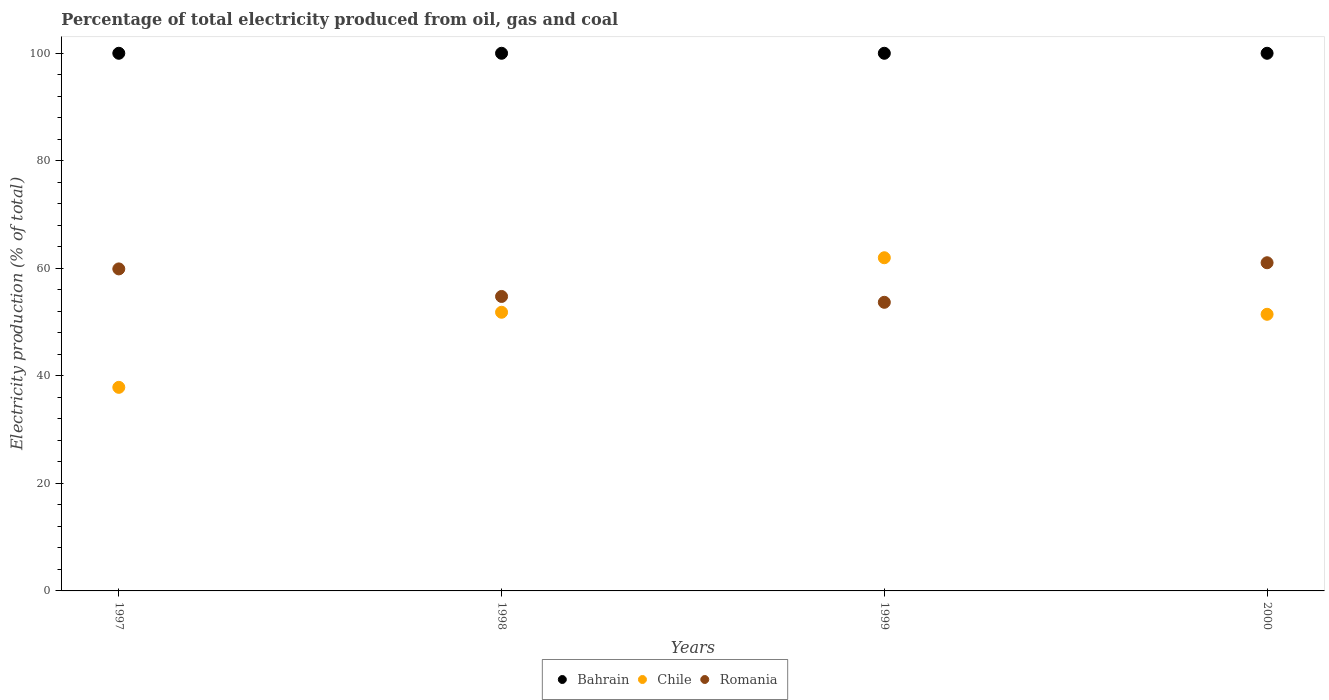What is the electricity production in in Romania in 2000?
Provide a succinct answer. 61.04. Across all years, what is the maximum electricity production in in Bahrain?
Provide a short and direct response. 100. Across all years, what is the minimum electricity production in in Bahrain?
Provide a succinct answer. 100. In which year was the electricity production in in Chile minimum?
Provide a short and direct response. 1997. What is the total electricity production in in Chile in the graph?
Provide a succinct answer. 203.12. What is the difference between the electricity production in in Bahrain in 1997 and that in 2000?
Your response must be concise. 0. What is the difference between the electricity production in in Chile in 1997 and the electricity production in in Romania in 2000?
Your answer should be compact. -23.17. What is the average electricity production in in Romania per year?
Keep it short and to the point. 57.35. In the year 2000, what is the difference between the electricity production in in Romania and electricity production in in Bahrain?
Your answer should be compact. -38.96. What is the ratio of the electricity production in in Romania in 1997 to that in 1998?
Provide a succinct answer. 1.09. What is the difference between the highest and the second highest electricity production in in Chile?
Provide a succinct answer. 10.14. What is the difference between the highest and the lowest electricity production in in Chile?
Give a very brief answer. 24.1. Is the sum of the electricity production in in Romania in 1997 and 1998 greater than the maximum electricity production in in Bahrain across all years?
Your response must be concise. Yes. Does the electricity production in in Chile monotonically increase over the years?
Make the answer very short. No. Is the electricity production in in Bahrain strictly less than the electricity production in in Romania over the years?
Ensure brevity in your answer.  No. How many dotlines are there?
Offer a terse response. 3. What is the difference between two consecutive major ticks on the Y-axis?
Provide a short and direct response. 20. What is the title of the graph?
Make the answer very short. Percentage of total electricity produced from oil, gas and coal. What is the label or title of the Y-axis?
Your answer should be compact. Electricity production (% of total). What is the Electricity production (% of total) of Bahrain in 1997?
Keep it short and to the point. 100. What is the Electricity production (% of total) of Chile in 1997?
Give a very brief answer. 37.87. What is the Electricity production (% of total) in Romania in 1997?
Make the answer very short. 59.89. What is the Electricity production (% of total) of Chile in 1998?
Provide a succinct answer. 51.83. What is the Electricity production (% of total) of Romania in 1998?
Your response must be concise. 54.77. What is the Electricity production (% of total) in Chile in 1999?
Provide a succinct answer. 61.97. What is the Electricity production (% of total) in Romania in 1999?
Keep it short and to the point. 53.68. What is the Electricity production (% of total) in Chile in 2000?
Your response must be concise. 51.45. What is the Electricity production (% of total) of Romania in 2000?
Offer a terse response. 61.04. Across all years, what is the maximum Electricity production (% of total) in Bahrain?
Offer a very short reply. 100. Across all years, what is the maximum Electricity production (% of total) in Chile?
Give a very brief answer. 61.97. Across all years, what is the maximum Electricity production (% of total) of Romania?
Provide a succinct answer. 61.04. Across all years, what is the minimum Electricity production (% of total) of Chile?
Your answer should be very brief. 37.87. Across all years, what is the minimum Electricity production (% of total) of Romania?
Provide a short and direct response. 53.68. What is the total Electricity production (% of total) in Bahrain in the graph?
Provide a succinct answer. 400. What is the total Electricity production (% of total) in Chile in the graph?
Your answer should be very brief. 203.12. What is the total Electricity production (% of total) in Romania in the graph?
Offer a terse response. 229.38. What is the difference between the Electricity production (% of total) in Chile in 1997 and that in 1998?
Your answer should be very brief. -13.96. What is the difference between the Electricity production (% of total) of Romania in 1997 and that in 1998?
Your answer should be compact. 5.12. What is the difference between the Electricity production (% of total) of Bahrain in 1997 and that in 1999?
Keep it short and to the point. 0. What is the difference between the Electricity production (% of total) in Chile in 1997 and that in 1999?
Your response must be concise. -24.1. What is the difference between the Electricity production (% of total) in Romania in 1997 and that in 1999?
Ensure brevity in your answer.  6.21. What is the difference between the Electricity production (% of total) in Bahrain in 1997 and that in 2000?
Your answer should be very brief. 0. What is the difference between the Electricity production (% of total) in Chile in 1997 and that in 2000?
Provide a succinct answer. -13.59. What is the difference between the Electricity production (% of total) of Romania in 1997 and that in 2000?
Offer a very short reply. -1.15. What is the difference between the Electricity production (% of total) of Bahrain in 1998 and that in 1999?
Provide a short and direct response. 0. What is the difference between the Electricity production (% of total) in Chile in 1998 and that in 1999?
Provide a succinct answer. -10.14. What is the difference between the Electricity production (% of total) of Romania in 1998 and that in 1999?
Make the answer very short. 1.09. What is the difference between the Electricity production (% of total) in Bahrain in 1998 and that in 2000?
Offer a terse response. 0. What is the difference between the Electricity production (% of total) of Chile in 1998 and that in 2000?
Ensure brevity in your answer.  0.38. What is the difference between the Electricity production (% of total) of Romania in 1998 and that in 2000?
Offer a very short reply. -6.27. What is the difference between the Electricity production (% of total) of Bahrain in 1999 and that in 2000?
Provide a succinct answer. 0. What is the difference between the Electricity production (% of total) of Chile in 1999 and that in 2000?
Your answer should be compact. 10.52. What is the difference between the Electricity production (% of total) of Romania in 1999 and that in 2000?
Your answer should be compact. -7.36. What is the difference between the Electricity production (% of total) of Bahrain in 1997 and the Electricity production (% of total) of Chile in 1998?
Keep it short and to the point. 48.17. What is the difference between the Electricity production (% of total) of Bahrain in 1997 and the Electricity production (% of total) of Romania in 1998?
Your answer should be compact. 45.23. What is the difference between the Electricity production (% of total) of Chile in 1997 and the Electricity production (% of total) of Romania in 1998?
Offer a terse response. -16.9. What is the difference between the Electricity production (% of total) in Bahrain in 1997 and the Electricity production (% of total) in Chile in 1999?
Your answer should be very brief. 38.03. What is the difference between the Electricity production (% of total) in Bahrain in 1997 and the Electricity production (% of total) in Romania in 1999?
Provide a succinct answer. 46.32. What is the difference between the Electricity production (% of total) of Chile in 1997 and the Electricity production (% of total) of Romania in 1999?
Ensure brevity in your answer.  -15.82. What is the difference between the Electricity production (% of total) in Bahrain in 1997 and the Electricity production (% of total) in Chile in 2000?
Ensure brevity in your answer.  48.55. What is the difference between the Electricity production (% of total) in Bahrain in 1997 and the Electricity production (% of total) in Romania in 2000?
Your response must be concise. 38.96. What is the difference between the Electricity production (% of total) in Chile in 1997 and the Electricity production (% of total) in Romania in 2000?
Offer a very short reply. -23.17. What is the difference between the Electricity production (% of total) in Bahrain in 1998 and the Electricity production (% of total) in Chile in 1999?
Keep it short and to the point. 38.03. What is the difference between the Electricity production (% of total) of Bahrain in 1998 and the Electricity production (% of total) of Romania in 1999?
Your answer should be compact. 46.32. What is the difference between the Electricity production (% of total) in Chile in 1998 and the Electricity production (% of total) in Romania in 1999?
Keep it short and to the point. -1.85. What is the difference between the Electricity production (% of total) in Bahrain in 1998 and the Electricity production (% of total) in Chile in 2000?
Your answer should be very brief. 48.55. What is the difference between the Electricity production (% of total) in Bahrain in 1998 and the Electricity production (% of total) in Romania in 2000?
Provide a short and direct response. 38.96. What is the difference between the Electricity production (% of total) in Chile in 1998 and the Electricity production (% of total) in Romania in 2000?
Your answer should be very brief. -9.21. What is the difference between the Electricity production (% of total) in Bahrain in 1999 and the Electricity production (% of total) in Chile in 2000?
Give a very brief answer. 48.55. What is the difference between the Electricity production (% of total) in Bahrain in 1999 and the Electricity production (% of total) in Romania in 2000?
Your answer should be compact. 38.96. What is the difference between the Electricity production (% of total) in Chile in 1999 and the Electricity production (% of total) in Romania in 2000?
Make the answer very short. 0.93. What is the average Electricity production (% of total) in Bahrain per year?
Keep it short and to the point. 100. What is the average Electricity production (% of total) in Chile per year?
Offer a terse response. 50.78. What is the average Electricity production (% of total) of Romania per year?
Ensure brevity in your answer.  57.35. In the year 1997, what is the difference between the Electricity production (% of total) of Bahrain and Electricity production (% of total) of Chile?
Offer a terse response. 62.13. In the year 1997, what is the difference between the Electricity production (% of total) in Bahrain and Electricity production (% of total) in Romania?
Keep it short and to the point. 40.11. In the year 1997, what is the difference between the Electricity production (% of total) in Chile and Electricity production (% of total) in Romania?
Provide a succinct answer. -22.03. In the year 1998, what is the difference between the Electricity production (% of total) in Bahrain and Electricity production (% of total) in Chile?
Provide a succinct answer. 48.17. In the year 1998, what is the difference between the Electricity production (% of total) in Bahrain and Electricity production (% of total) in Romania?
Ensure brevity in your answer.  45.23. In the year 1998, what is the difference between the Electricity production (% of total) in Chile and Electricity production (% of total) in Romania?
Your response must be concise. -2.94. In the year 1999, what is the difference between the Electricity production (% of total) in Bahrain and Electricity production (% of total) in Chile?
Provide a short and direct response. 38.03. In the year 1999, what is the difference between the Electricity production (% of total) of Bahrain and Electricity production (% of total) of Romania?
Provide a succinct answer. 46.32. In the year 1999, what is the difference between the Electricity production (% of total) in Chile and Electricity production (% of total) in Romania?
Offer a terse response. 8.29. In the year 2000, what is the difference between the Electricity production (% of total) of Bahrain and Electricity production (% of total) of Chile?
Make the answer very short. 48.55. In the year 2000, what is the difference between the Electricity production (% of total) in Bahrain and Electricity production (% of total) in Romania?
Offer a terse response. 38.96. In the year 2000, what is the difference between the Electricity production (% of total) of Chile and Electricity production (% of total) of Romania?
Keep it short and to the point. -9.59. What is the ratio of the Electricity production (% of total) of Bahrain in 1997 to that in 1998?
Make the answer very short. 1. What is the ratio of the Electricity production (% of total) in Chile in 1997 to that in 1998?
Ensure brevity in your answer.  0.73. What is the ratio of the Electricity production (% of total) in Romania in 1997 to that in 1998?
Offer a terse response. 1.09. What is the ratio of the Electricity production (% of total) in Chile in 1997 to that in 1999?
Your answer should be compact. 0.61. What is the ratio of the Electricity production (% of total) of Romania in 1997 to that in 1999?
Ensure brevity in your answer.  1.12. What is the ratio of the Electricity production (% of total) in Chile in 1997 to that in 2000?
Provide a succinct answer. 0.74. What is the ratio of the Electricity production (% of total) in Romania in 1997 to that in 2000?
Give a very brief answer. 0.98. What is the ratio of the Electricity production (% of total) of Chile in 1998 to that in 1999?
Give a very brief answer. 0.84. What is the ratio of the Electricity production (% of total) in Romania in 1998 to that in 1999?
Provide a succinct answer. 1.02. What is the ratio of the Electricity production (% of total) of Chile in 1998 to that in 2000?
Provide a short and direct response. 1.01. What is the ratio of the Electricity production (% of total) in Romania in 1998 to that in 2000?
Your answer should be very brief. 0.9. What is the ratio of the Electricity production (% of total) in Bahrain in 1999 to that in 2000?
Your answer should be very brief. 1. What is the ratio of the Electricity production (% of total) of Chile in 1999 to that in 2000?
Offer a terse response. 1.2. What is the ratio of the Electricity production (% of total) in Romania in 1999 to that in 2000?
Your answer should be very brief. 0.88. What is the difference between the highest and the second highest Electricity production (% of total) in Bahrain?
Ensure brevity in your answer.  0. What is the difference between the highest and the second highest Electricity production (% of total) of Chile?
Offer a terse response. 10.14. What is the difference between the highest and the second highest Electricity production (% of total) in Romania?
Keep it short and to the point. 1.15. What is the difference between the highest and the lowest Electricity production (% of total) in Chile?
Keep it short and to the point. 24.1. What is the difference between the highest and the lowest Electricity production (% of total) in Romania?
Give a very brief answer. 7.36. 